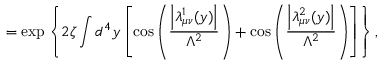<formula> <loc_0><loc_0><loc_500><loc_500>= \exp \left \{ 2 \zeta \int d ^ { 4 } y \left [ \cos \left ( \frac { \left | \lambda _ { \mu \nu } ^ { 1 } ( y ) \right | } { \Lambda ^ { 2 } } \right ) + \cos \left ( \frac { \left | \lambda _ { \mu \nu } ^ { 2 } ( y ) \right | } { \Lambda ^ { 2 } } \right ) \right ] \right \} ,</formula> 